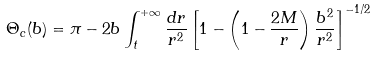<formula> <loc_0><loc_0><loc_500><loc_500>\Theta _ { c } ( b ) = \pi - 2 b \int _ { t } ^ { + \infty } \frac { d r } { r ^ { 2 } } \left [ 1 - \left ( 1 - \frac { 2 M } { r } \right ) \frac { b ^ { 2 } } { r ^ { 2 } } \right ] ^ { - 1 / 2 }</formula> 